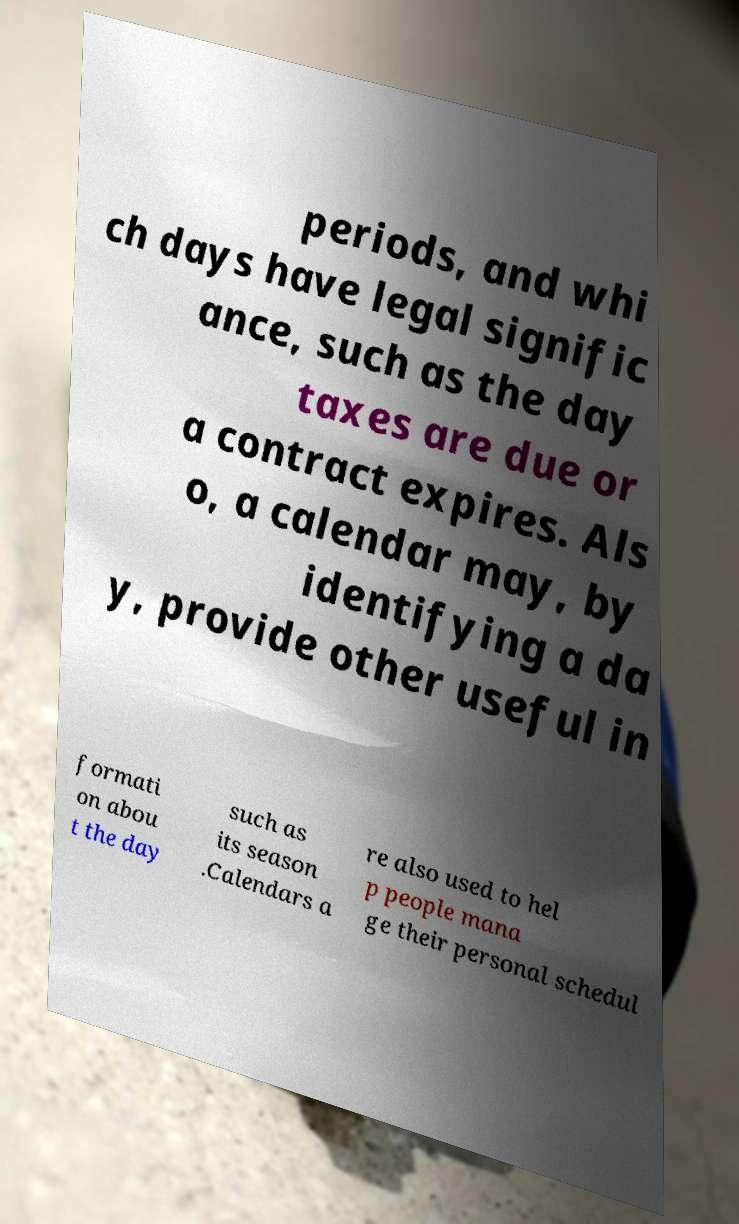For documentation purposes, I need the text within this image transcribed. Could you provide that? periods, and whi ch days have legal signific ance, such as the day taxes are due or a contract expires. Als o, a calendar may, by identifying a da y, provide other useful in formati on abou t the day such as its season .Calendars a re also used to hel p people mana ge their personal schedul 